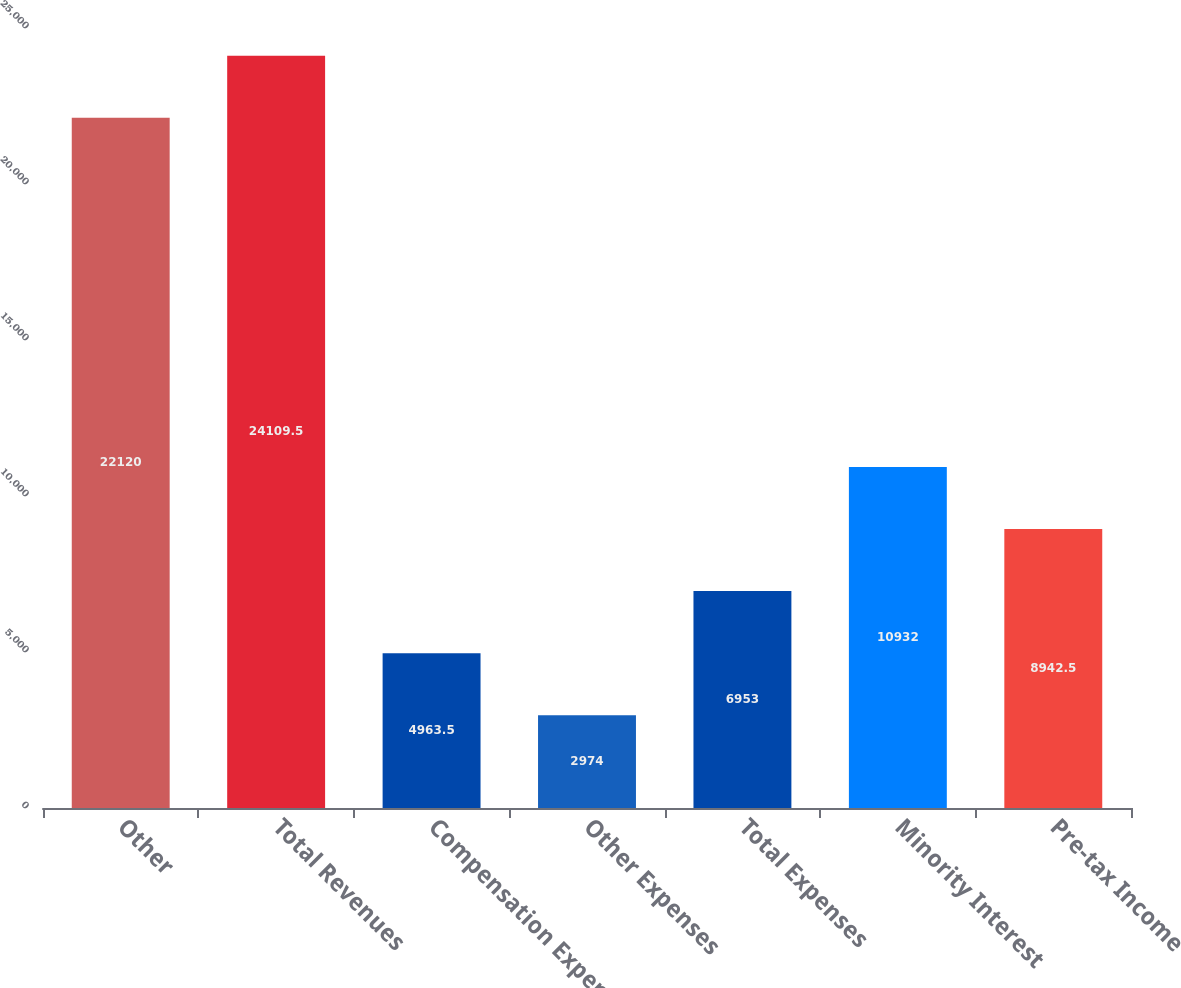<chart> <loc_0><loc_0><loc_500><loc_500><bar_chart><fcel>Other<fcel>Total Revenues<fcel>Compensation Expense<fcel>Other Expenses<fcel>Total Expenses<fcel>Minority Interest<fcel>Pre-tax Income<nl><fcel>22120<fcel>24109.5<fcel>4963.5<fcel>2974<fcel>6953<fcel>10932<fcel>8942.5<nl></chart> 